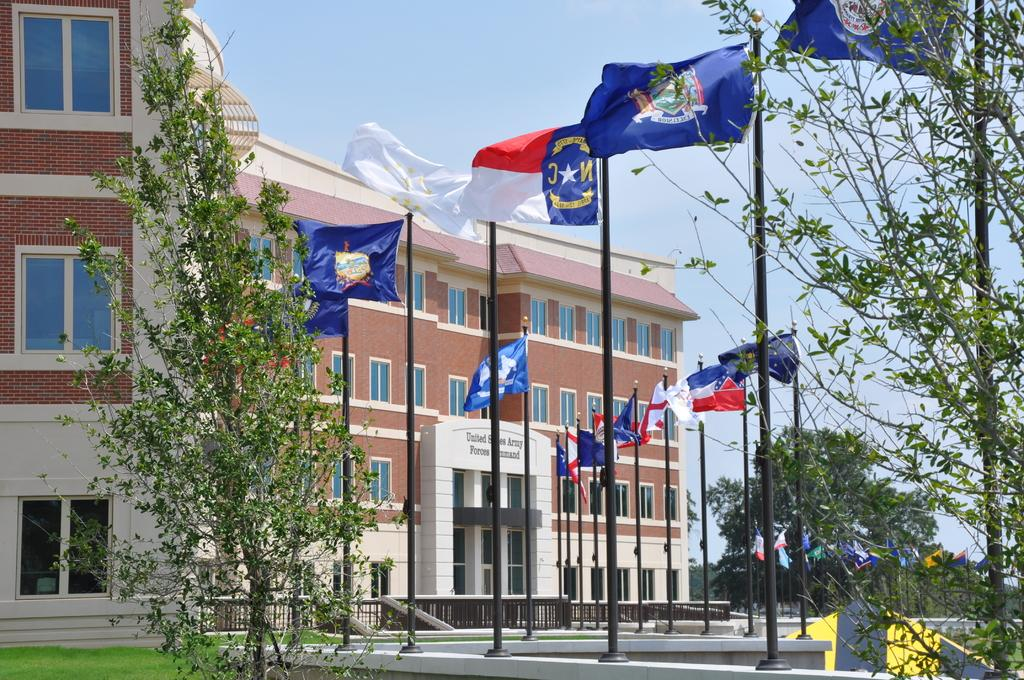What structure is the main focus of the image? There is a building in the image. What is located in front of the building? There are flags, stands, trees, and a road in front of the building. What can be seen in the sky in the image? The sky is visible at the top of the image. What type of rod can be seen in the sea near the building in the image? There is no sea or rod present in the image; it features a building with objects and features in front of it, as well as a visible sky. 